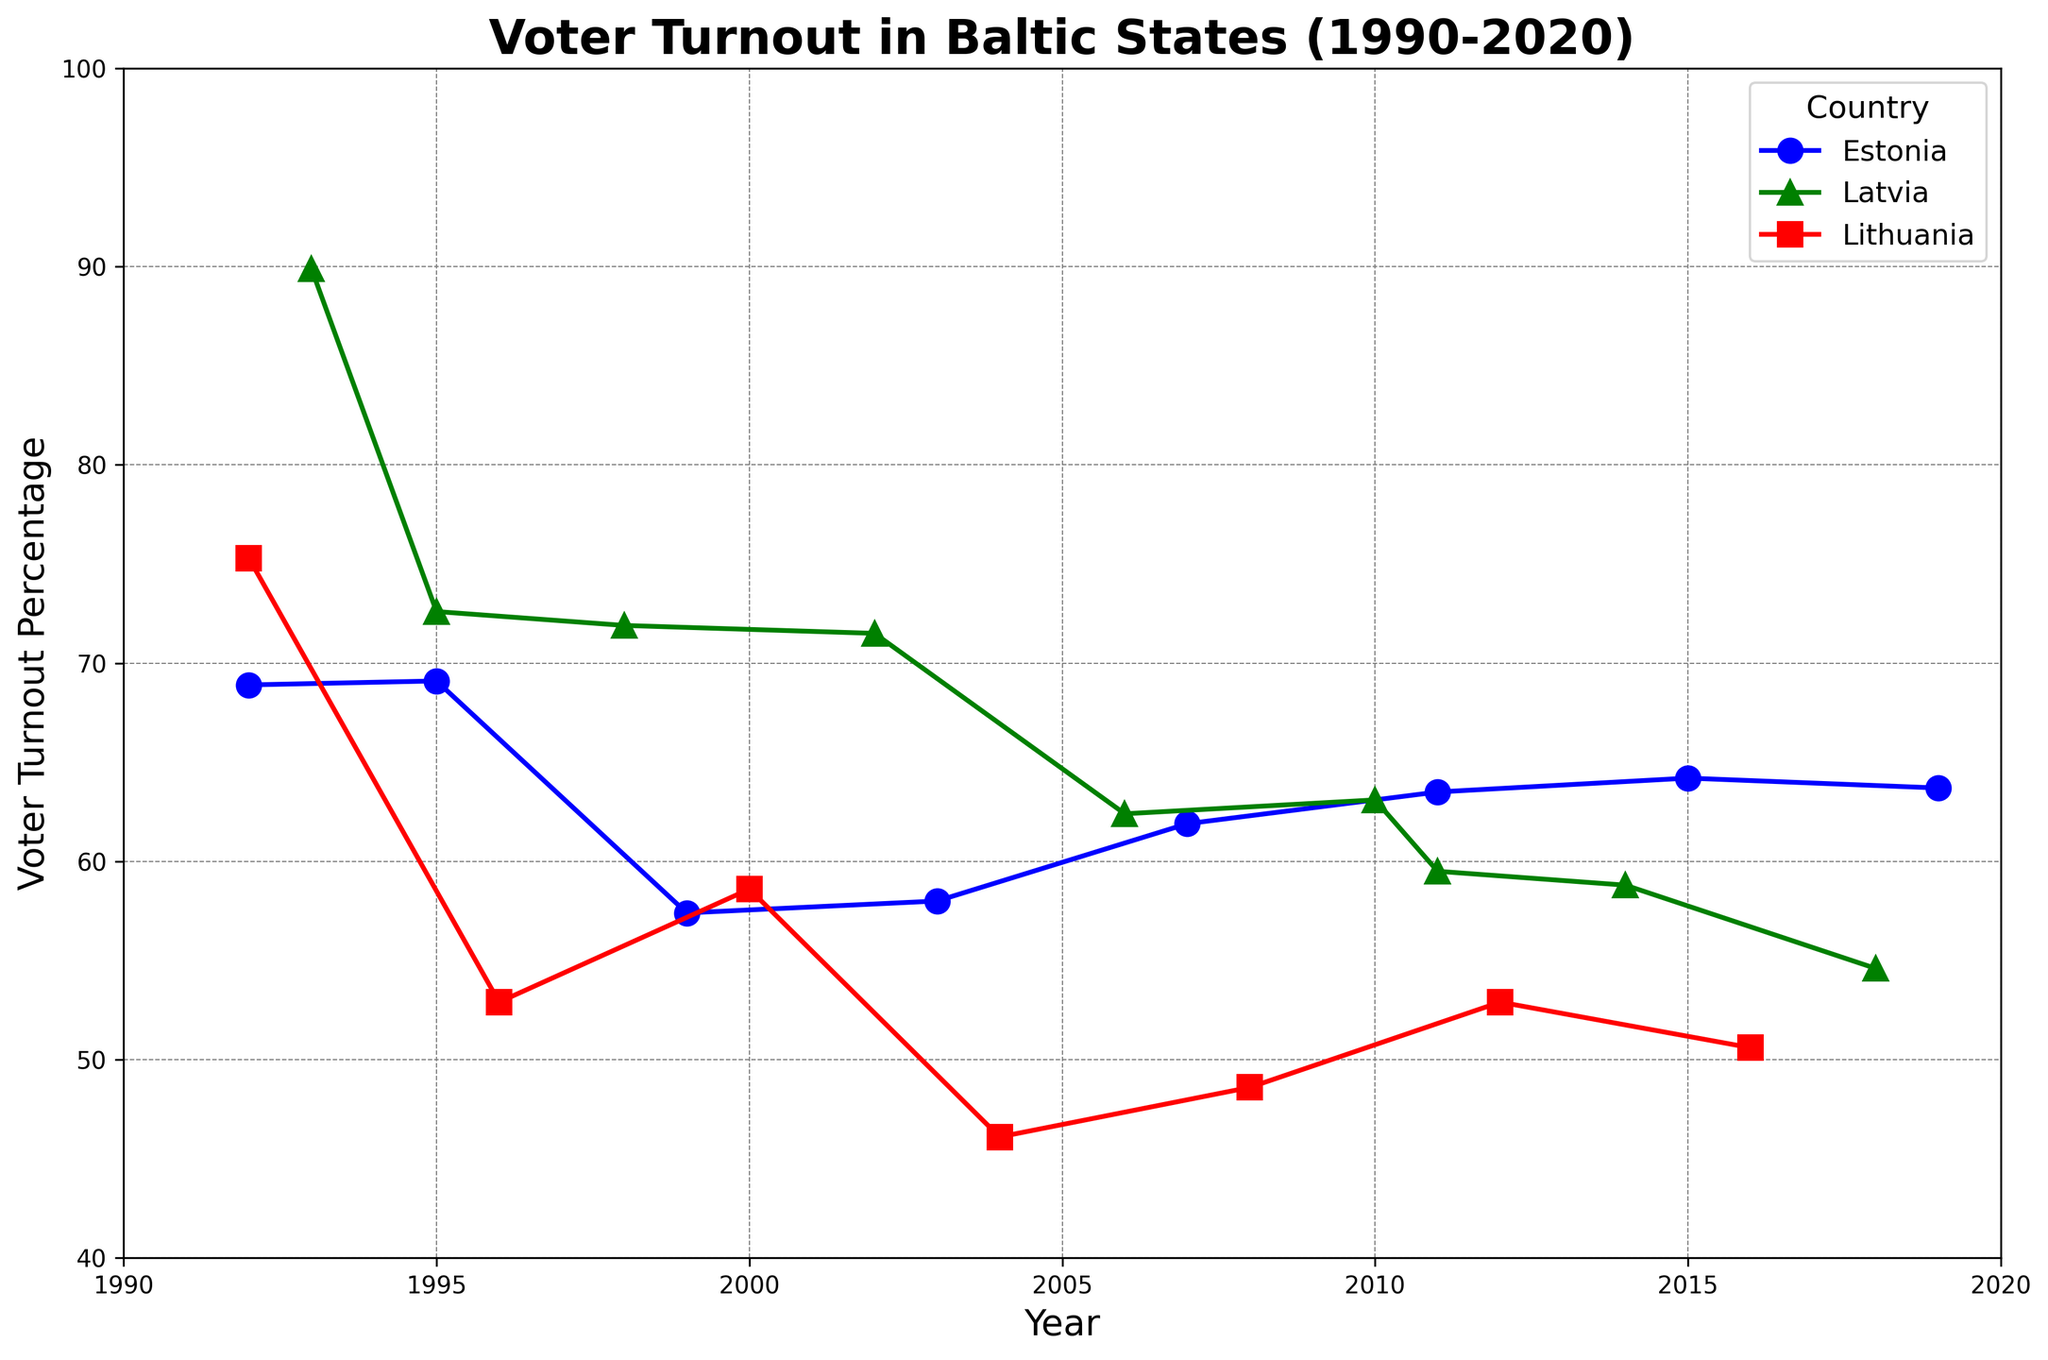What is the highest voter turnout for Estonia, and in which year did it occur? The highest voter turnout for Estonia can be seen by identifying the peak point on the line corresponding to Estonia. The highest value reaches 69.1%, which occurred in the year 1995.
Answer: 69.1% in 1995 Between Latvia and Lithuania, which country had a higher voter turnout in 2012? To find this, locate the points for Latvia and Lithuania in the year 2012 on the graph. Latvia does not have a data point for 2012, but Lithuania does, with a voter turnout of 52.9%. Hence, Lithuania had a higher voter turnout.
Answer: Lithuania What is the average voter turnout for Latvia over the displayed period? To calculate the average, sum all the voter turnout percentages for Latvia and divide by the number of data points. The data points for Latvia are 89.9, 72.6, 71.9, 71.5, 62.4, 63.1, 59.5, 58.8, and 54.6. Thus, the sum is 604.3, and the count is 9, so the average is 604.3/9 = 67.14%.
Answer: 67.14% During which election year did Lithuania experience its lowest voter turnout, and what was the percentage? To determine this, find the lowest point on Lithuania's line in the graph. The lowest turnout for Lithuania occurred in 2004 with a voter turnout of 46.1%.
Answer: 2004 at 46.1% Did Estonia's voter turnout generally increase or decrease from 1992 to 2019? Observe the general trend of the line representing Estonia from the first to the last data point. The turnout starts from 68.9% in 1992 and ends at 63.7% in 2019. The overall trend shows a slight decrease.
Answer: Decrease How many years had Lithuania's voter turnout less than 50%? Identify the data points on Lithuania's line that fall below the 50% mark. These occur in 2004 (46.1%) and 2016 (50.6% is just below threshold). That means there are 2 years where it is below 50%.
Answer: 2 Which country had the most stable voter turnout trend over the period? Stability can be judged by how flat the line is across the years. Latvia's voter turnout shows lower variability compared to Estonia and Lithuania, which have more pronounced fluctuations.
Answer: Latvia In which year did Latvia experience a significant drop in voter turnout, and what was the percentage change compared to the previous election? Identify the year where a significant drop happens in Latvia's line. A notable drop is observed from 2006 (62.4%) to 2010 (63.1%), then a sudden drop to 2011 (59.5%). This change from 2010 to 2011 represents a 3.6% drop.
Answer: 2011 with a 3.6% decrease 